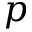Convert formula to latex. <formula><loc_0><loc_0><loc_500><loc_500>p</formula> 